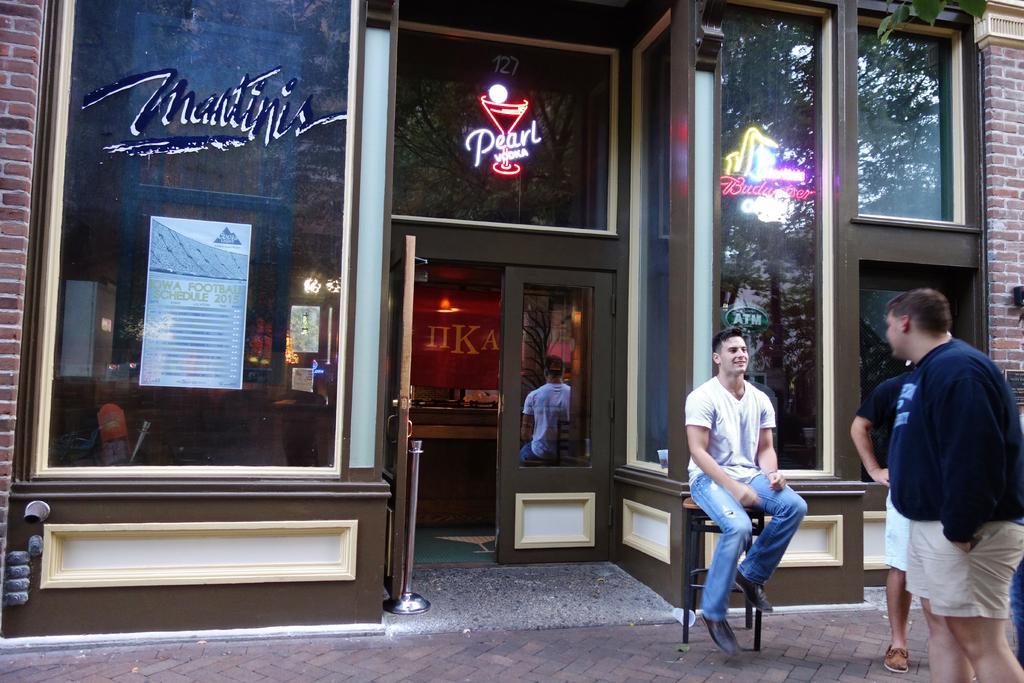Can you describe this image briefly? On the right side, there are two persons in t-shirts standing on the footpath, near a person who is in white color t-shirt, sitting on a stool. Beside them, there is a building. Which is having glass windows and hoardings. Inside the building, there are other other objects. 